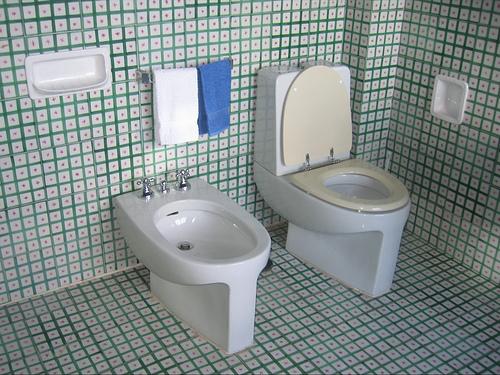Is that a bidet next to the toilet?
Keep it brief. Yes. Which room is this?
Write a very short answer. Bathroom. What color towel is on the left?
Answer briefly. White. 